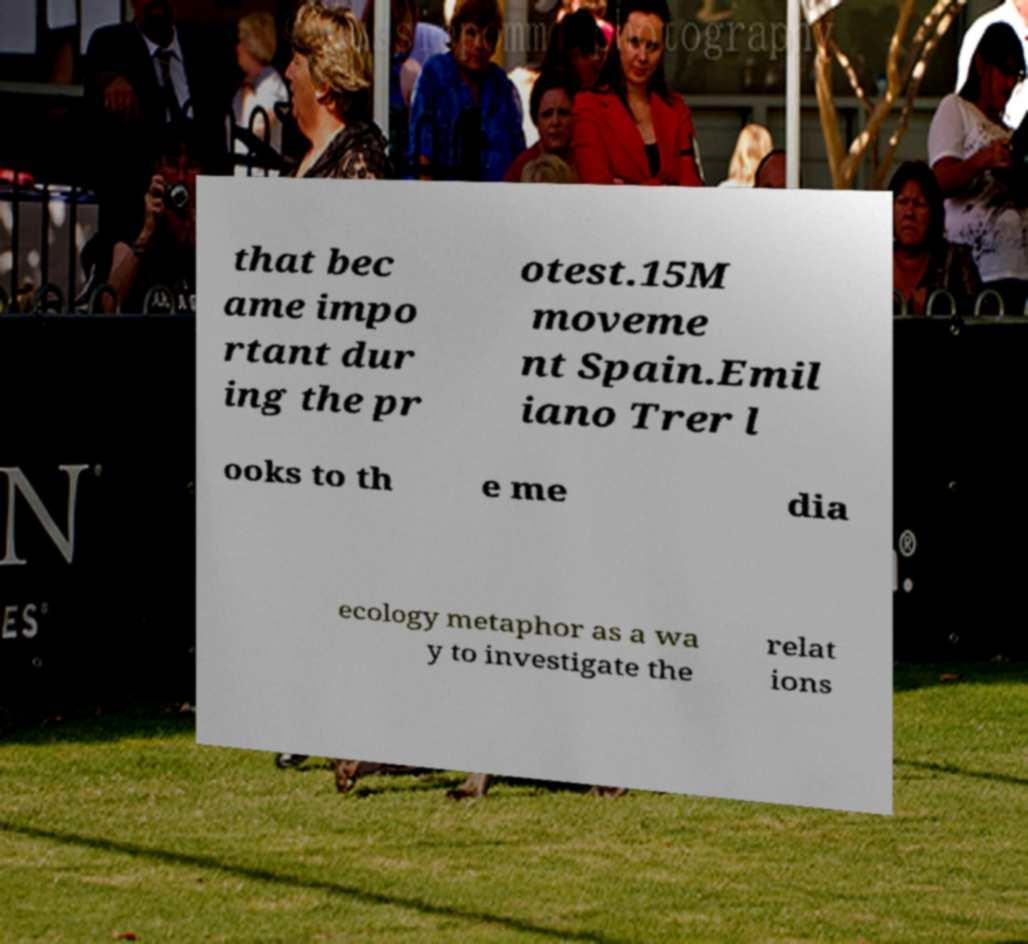Can you read and provide the text displayed in the image?This photo seems to have some interesting text. Can you extract and type it out for me? that bec ame impo rtant dur ing the pr otest.15M moveme nt Spain.Emil iano Trer l ooks to th e me dia ecology metaphor as a wa y to investigate the relat ions 